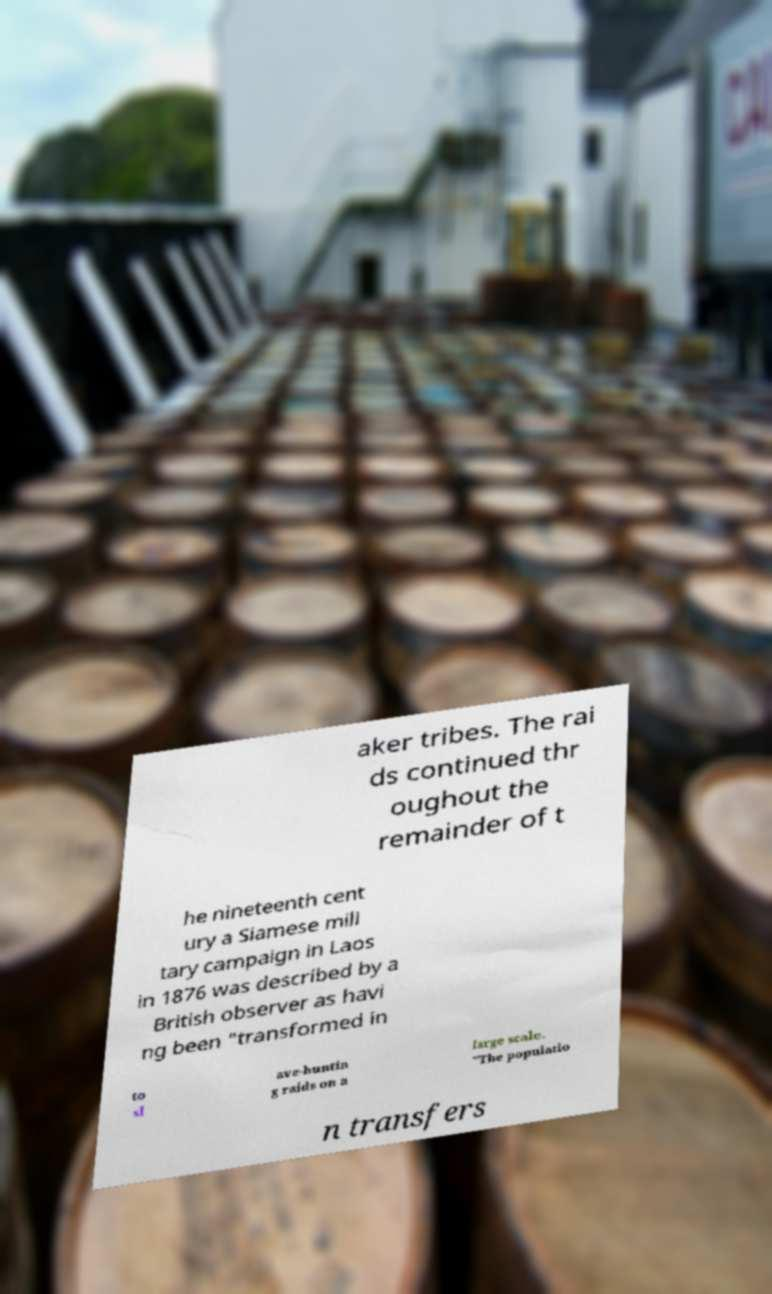Please read and relay the text visible in this image. What does it say? aker tribes. The rai ds continued thr oughout the remainder of t he nineteenth cent ury a Siamese mili tary campaign in Laos in 1876 was described by a British observer as havi ng been "transformed in to sl ave-huntin g raids on a large scale. "The populatio n transfers 